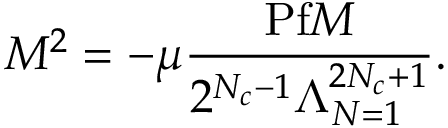Convert formula to latex. <formula><loc_0><loc_0><loc_500><loc_500>M ^ { 2 } = - \mu \frac { P f M } { 2 ^ { N _ { c } - 1 } \Lambda _ { N = 1 } ^ { 2 N _ { c } + 1 } } .</formula> 